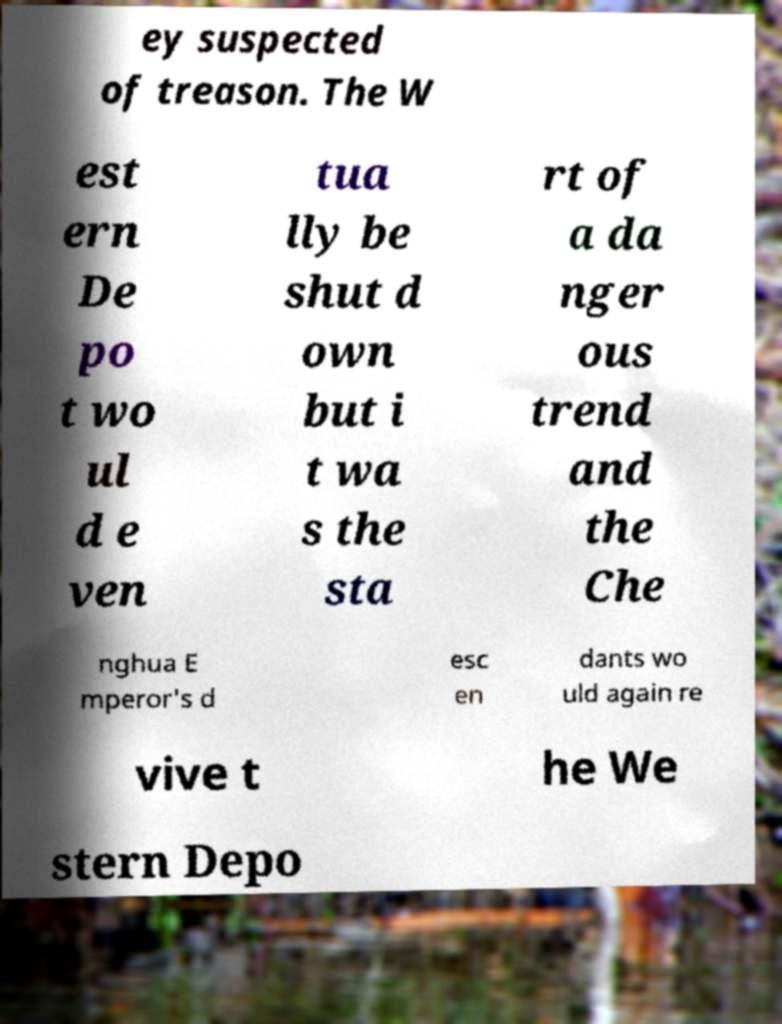I need the written content from this picture converted into text. Can you do that? ey suspected of treason. The W est ern De po t wo ul d e ven tua lly be shut d own but i t wa s the sta rt of a da nger ous trend and the Che nghua E mperor's d esc en dants wo uld again re vive t he We stern Depo 